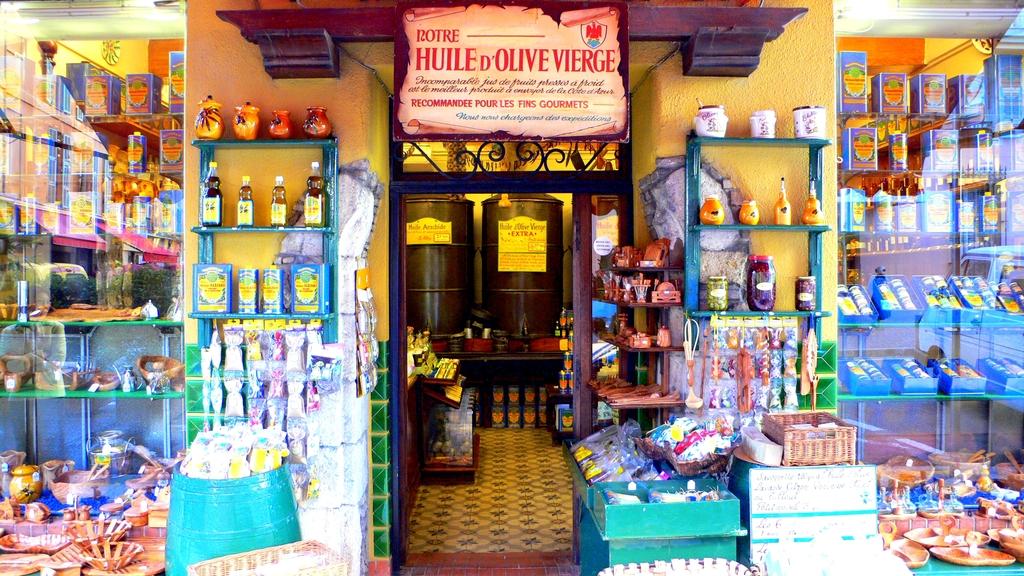What is the name of the shop?
Keep it short and to the point. Huile d'olive vierge. 